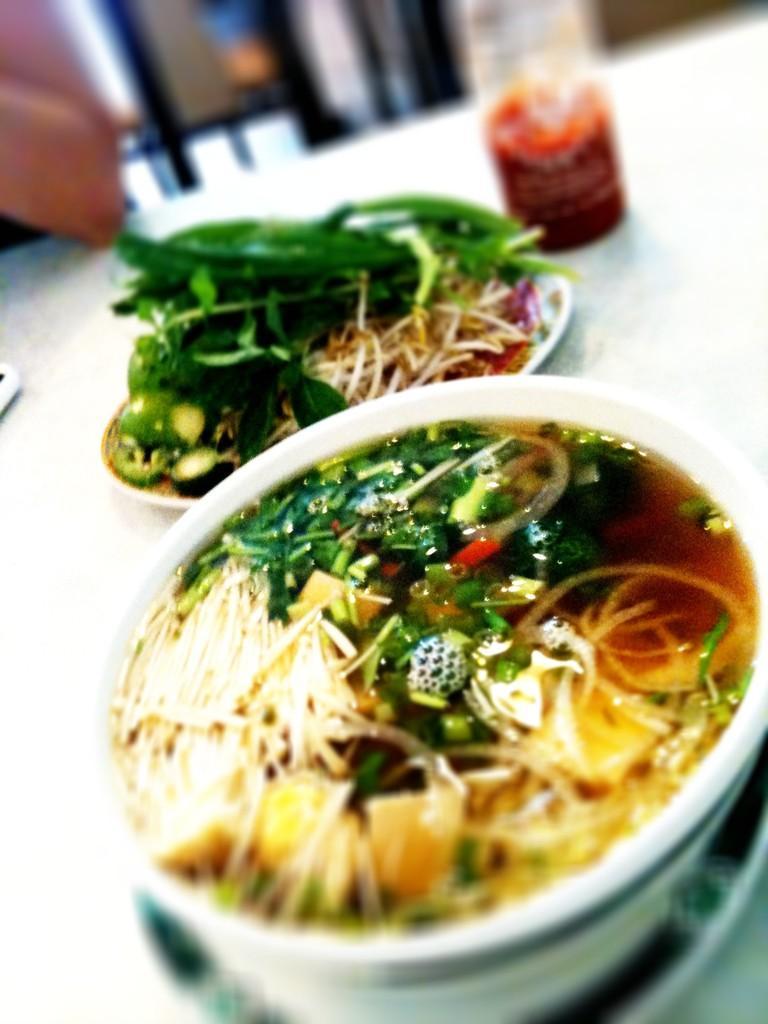In one or two sentences, can you explain what this image depicts? In this image I see a bowl which is of white in color and I see food in it which is of cream, green and red in color and I see a plate over here on which there is food and it is of green and cream in color and I see a bottle over here in which there is red color semi solid thing and these all are on a white surface and I see a person's hand over here. In the background it is blurred. 